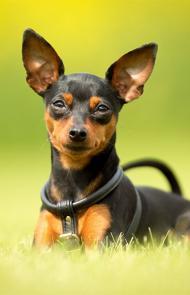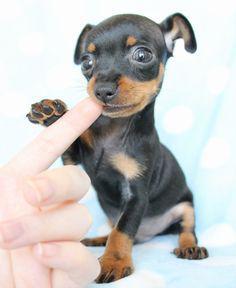The first image is the image on the left, the second image is the image on the right. Considering the images on both sides, is "There is a puppy biting a finger in one of the images." valid? Answer yes or no. Yes. The first image is the image on the left, the second image is the image on the right. Assess this claim about the two images: "One image shows a human hand interacting with a juvenile dog.". Correct or not? Answer yes or no. Yes. 